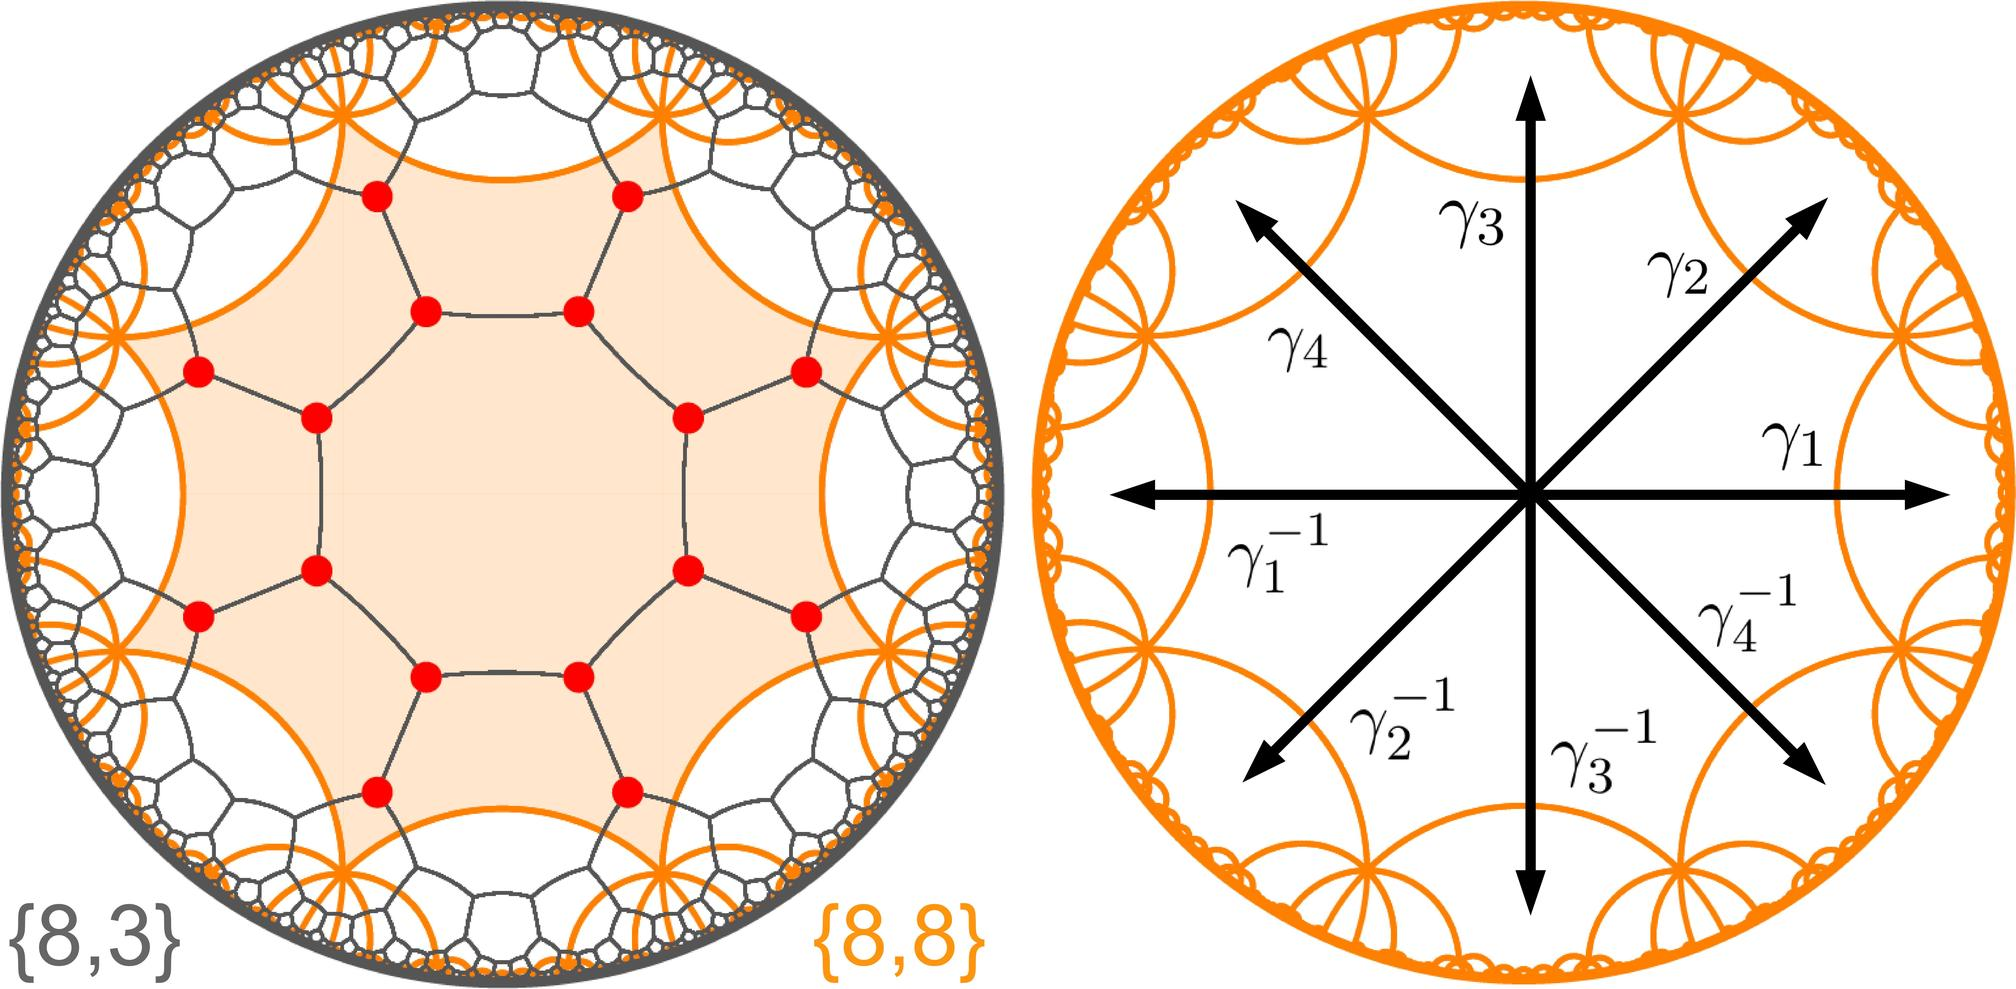What do the symbols \(\gamma_1, \gamma_2, \gamma_3, \gamma_4\) in the right figure represent? A. Directions of magnetic fields B. Different phases of a substance C. Eigenvalues of a matrix D. Roots of a polynomial equation The symbols \(\gamma_1, \gamma_2, \gamma_3, \gamma_4\) in the right figure represent the roots of a polynomial equation. Each symbol points to a specific value on the complex plane, shown in pairs with their respective negative counterparts. This pairing indicates that each root and its negative are solutions to the same polynomial equation. This visualization is common in complex analysis, where roots are graphically represented to provide insights into their symmetrical relationships and implications in solving polynomial equations. 